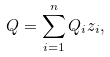<formula> <loc_0><loc_0><loc_500><loc_500>Q = \sum _ { i = 1 } ^ { n } Q _ { i } z _ { i } ,</formula> 